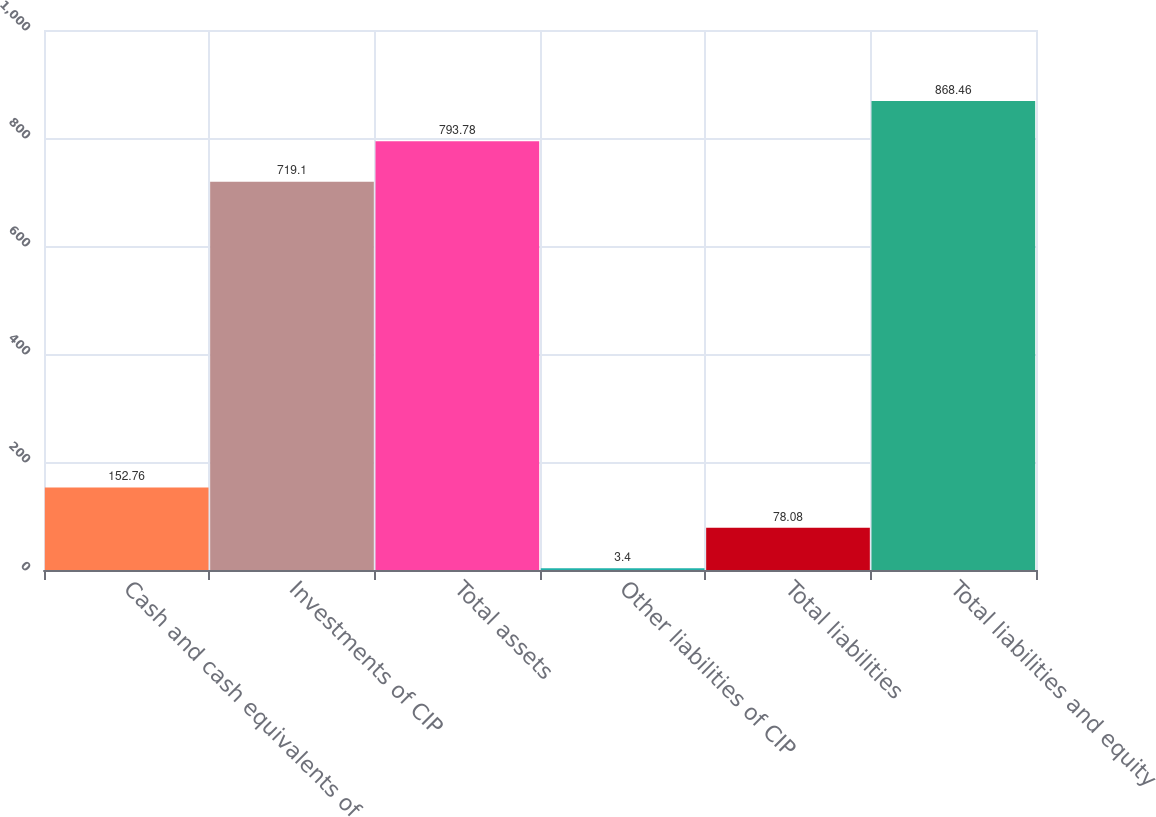Convert chart to OTSL. <chart><loc_0><loc_0><loc_500><loc_500><bar_chart><fcel>Cash and cash equivalents of<fcel>Investments of CIP<fcel>Total assets<fcel>Other liabilities of CIP<fcel>Total liabilities<fcel>Total liabilities and equity<nl><fcel>152.76<fcel>719.1<fcel>793.78<fcel>3.4<fcel>78.08<fcel>868.46<nl></chart> 